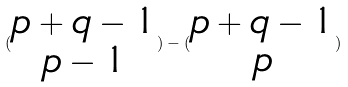<formula> <loc_0><loc_0><loc_500><loc_500>( \begin{matrix} p + q - 1 \\ p - 1 \end{matrix} ) - ( \begin{matrix} p + q - 1 \\ p \end{matrix} )</formula> 